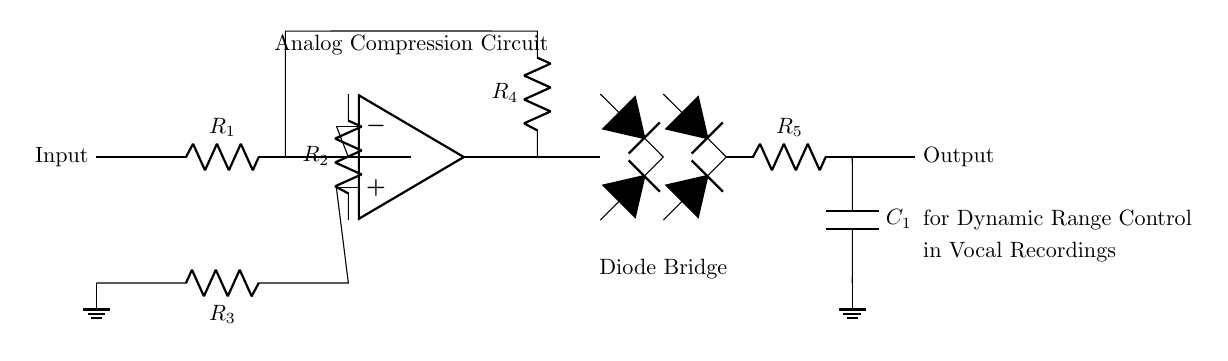What is the main function of this circuit? The main function of this circuit is to compress the dynamic range of vocal recordings. This is evident as it is labeled under "Analog Compression Circuit" and includes components typical for dynamic range control.
Answer: Compression Which component is used for signal feedback? The operational amplifier (op amp) in the circuit is responsible for signal feedback. It connects to the resistors forming the feedback network back to the input.
Answer: Operational amplifier What does the diode bridge provide in this circuit? The diode bridge allows for rectification of the audio signal, ensuring the circuit can handle both positive and negative signal amplitudes efficiently. This is necessary for dynamic range control.
Answer: Rectification What are the values of resistors in series before the operational amplifier? The resistors in series before the operational amplifier are R1, R2, and R4, which are crucial for setting the gain of the op amp and forming part of the feedback loop.
Answer: R1 and R2 What is the configuration of the input stage? The input stage consists of a resistor (R1) followed by an operational amplifier, which amplifies and compresses the input signal, making it suitable for the subsequent processing stages.
Answer: Resistor and op amp What happens at the output stage of the circuit? At the output stage, the output signal passes through resistor R5 and capacitor C1, which smooths out the signal and helps eliminate high-frequency noise, resulting in a cleaner audio output.
Answer: Smoothing 